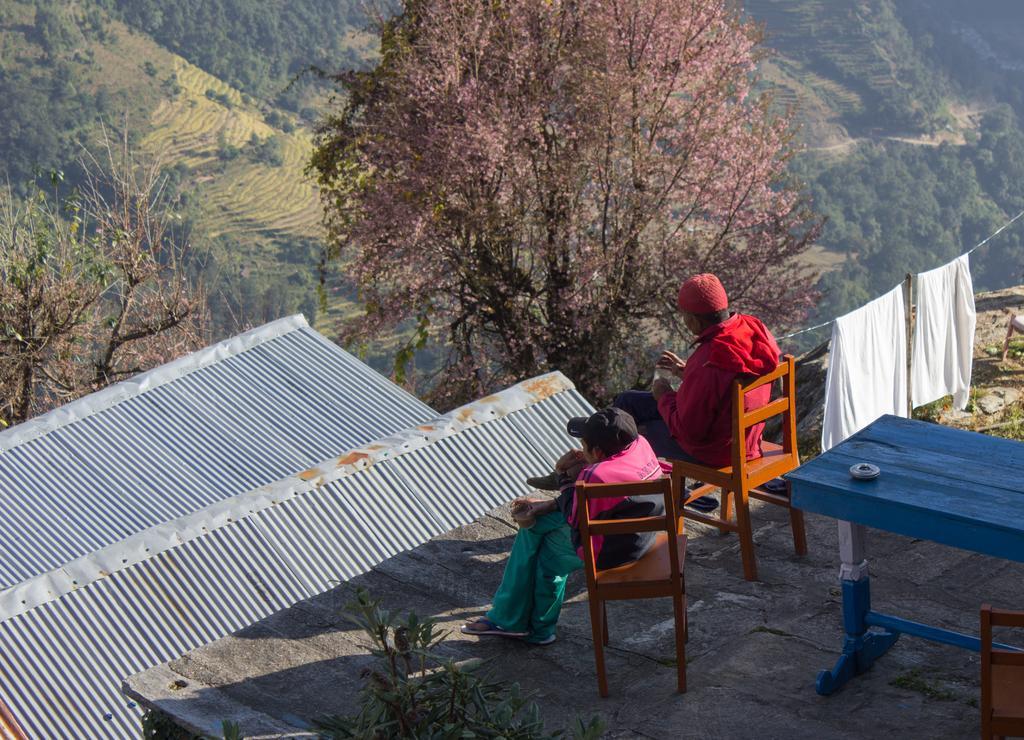Please provide a concise description of this image. In this picture there is a man and woman those who are sitting on the roof, there is a table behind them it is a forest area, there are so many trees around the area of the image. 